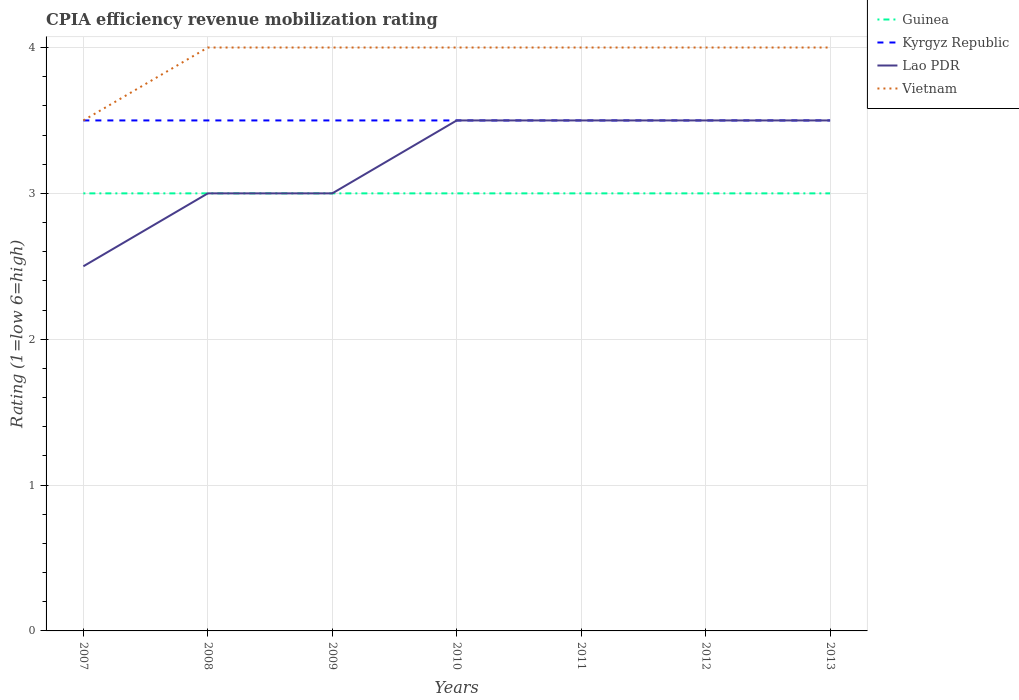Does the line corresponding to Vietnam intersect with the line corresponding to Kyrgyz Republic?
Give a very brief answer. Yes. In which year was the CPIA rating in Vietnam maximum?
Give a very brief answer. 2007. How many lines are there?
Make the answer very short. 4. What is the difference between two consecutive major ticks on the Y-axis?
Provide a short and direct response. 1. Are the values on the major ticks of Y-axis written in scientific E-notation?
Provide a succinct answer. No. Does the graph contain any zero values?
Keep it short and to the point. No. Does the graph contain grids?
Your answer should be compact. Yes. Where does the legend appear in the graph?
Ensure brevity in your answer.  Top right. What is the title of the graph?
Offer a terse response. CPIA efficiency revenue mobilization rating. Does "Marshall Islands" appear as one of the legend labels in the graph?
Your answer should be compact. No. What is the label or title of the X-axis?
Ensure brevity in your answer.  Years. What is the label or title of the Y-axis?
Ensure brevity in your answer.  Rating (1=low 6=high). What is the Rating (1=low 6=high) in Guinea in 2007?
Offer a terse response. 3. What is the Rating (1=low 6=high) of Guinea in 2008?
Your response must be concise. 3. What is the Rating (1=low 6=high) in Kyrgyz Republic in 2008?
Provide a succinct answer. 3.5. What is the Rating (1=low 6=high) in Lao PDR in 2008?
Offer a very short reply. 3. What is the Rating (1=low 6=high) in Kyrgyz Republic in 2009?
Give a very brief answer. 3.5. What is the Rating (1=low 6=high) of Guinea in 2010?
Your response must be concise. 3. What is the Rating (1=low 6=high) in Vietnam in 2010?
Provide a succinct answer. 4. What is the Rating (1=low 6=high) of Guinea in 2011?
Offer a very short reply. 3. What is the Rating (1=low 6=high) of Vietnam in 2011?
Make the answer very short. 4. What is the Rating (1=low 6=high) of Kyrgyz Republic in 2012?
Provide a succinct answer. 3.5. What is the Rating (1=low 6=high) in Lao PDR in 2012?
Offer a very short reply. 3.5. Across all years, what is the maximum Rating (1=low 6=high) in Guinea?
Provide a short and direct response. 3. Across all years, what is the maximum Rating (1=low 6=high) in Vietnam?
Offer a very short reply. 4. What is the total Rating (1=low 6=high) of Vietnam in the graph?
Ensure brevity in your answer.  27.5. What is the difference between the Rating (1=low 6=high) of Kyrgyz Republic in 2007 and that in 2008?
Your response must be concise. 0. What is the difference between the Rating (1=low 6=high) in Lao PDR in 2007 and that in 2008?
Ensure brevity in your answer.  -0.5. What is the difference between the Rating (1=low 6=high) of Kyrgyz Republic in 2007 and that in 2009?
Provide a short and direct response. 0. What is the difference between the Rating (1=low 6=high) of Lao PDR in 2007 and that in 2009?
Offer a terse response. -0.5. What is the difference between the Rating (1=low 6=high) in Guinea in 2007 and that in 2010?
Offer a terse response. 0. What is the difference between the Rating (1=low 6=high) in Lao PDR in 2007 and that in 2010?
Your answer should be compact. -1. What is the difference between the Rating (1=low 6=high) of Guinea in 2007 and that in 2011?
Keep it short and to the point. 0. What is the difference between the Rating (1=low 6=high) of Vietnam in 2007 and that in 2011?
Offer a very short reply. -0.5. What is the difference between the Rating (1=low 6=high) in Kyrgyz Republic in 2007 and that in 2013?
Make the answer very short. 0. What is the difference between the Rating (1=low 6=high) of Lao PDR in 2007 and that in 2013?
Your answer should be very brief. -1. What is the difference between the Rating (1=low 6=high) in Kyrgyz Republic in 2008 and that in 2009?
Your answer should be compact. 0. What is the difference between the Rating (1=low 6=high) of Guinea in 2008 and that in 2010?
Ensure brevity in your answer.  0. What is the difference between the Rating (1=low 6=high) in Kyrgyz Republic in 2008 and that in 2010?
Your response must be concise. 0. What is the difference between the Rating (1=low 6=high) of Vietnam in 2008 and that in 2010?
Provide a succinct answer. 0. What is the difference between the Rating (1=low 6=high) of Guinea in 2008 and that in 2011?
Offer a very short reply. 0. What is the difference between the Rating (1=low 6=high) in Lao PDR in 2008 and that in 2011?
Make the answer very short. -0.5. What is the difference between the Rating (1=low 6=high) of Kyrgyz Republic in 2008 and that in 2012?
Your response must be concise. 0. What is the difference between the Rating (1=low 6=high) in Lao PDR in 2008 and that in 2012?
Your response must be concise. -0.5. What is the difference between the Rating (1=low 6=high) in Guinea in 2008 and that in 2013?
Offer a terse response. 0. What is the difference between the Rating (1=low 6=high) in Lao PDR in 2008 and that in 2013?
Provide a succinct answer. -0.5. What is the difference between the Rating (1=low 6=high) in Lao PDR in 2009 and that in 2010?
Provide a succinct answer. -0.5. What is the difference between the Rating (1=low 6=high) in Lao PDR in 2009 and that in 2011?
Give a very brief answer. -0.5. What is the difference between the Rating (1=low 6=high) in Vietnam in 2009 and that in 2011?
Make the answer very short. 0. What is the difference between the Rating (1=low 6=high) in Lao PDR in 2009 and that in 2012?
Offer a very short reply. -0.5. What is the difference between the Rating (1=low 6=high) in Vietnam in 2009 and that in 2013?
Ensure brevity in your answer.  0. What is the difference between the Rating (1=low 6=high) of Guinea in 2010 and that in 2011?
Offer a very short reply. 0. What is the difference between the Rating (1=low 6=high) in Kyrgyz Republic in 2010 and that in 2011?
Ensure brevity in your answer.  0. What is the difference between the Rating (1=low 6=high) of Vietnam in 2010 and that in 2011?
Your answer should be very brief. 0. What is the difference between the Rating (1=low 6=high) in Kyrgyz Republic in 2010 and that in 2012?
Ensure brevity in your answer.  0. What is the difference between the Rating (1=low 6=high) of Vietnam in 2010 and that in 2012?
Your response must be concise. 0. What is the difference between the Rating (1=low 6=high) in Guinea in 2010 and that in 2013?
Your answer should be compact. 0. What is the difference between the Rating (1=low 6=high) in Vietnam in 2010 and that in 2013?
Ensure brevity in your answer.  0. What is the difference between the Rating (1=low 6=high) of Kyrgyz Republic in 2011 and that in 2012?
Offer a terse response. 0. What is the difference between the Rating (1=low 6=high) of Vietnam in 2011 and that in 2012?
Provide a short and direct response. 0. What is the difference between the Rating (1=low 6=high) of Guinea in 2011 and that in 2013?
Ensure brevity in your answer.  0. What is the difference between the Rating (1=low 6=high) of Kyrgyz Republic in 2011 and that in 2013?
Your answer should be very brief. 0. What is the difference between the Rating (1=low 6=high) in Guinea in 2012 and that in 2013?
Ensure brevity in your answer.  0. What is the difference between the Rating (1=low 6=high) of Kyrgyz Republic in 2012 and that in 2013?
Provide a succinct answer. 0. What is the difference between the Rating (1=low 6=high) of Guinea in 2007 and the Rating (1=low 6=high) of Kyrgyz Republic in 2008?
Offer a terse response. -0.5. What is the difference between the Rating (1=low 6=high) in Guinea in 2007 and the Rating (1=low 6=high) in Vietnam in 2008?
Your response must be concise. -1. What is the difference between the Rating (1=low 6=high) in Kyrgyz Republic in 2007 and the Rating (1=low 6=high) in Lao PDR in 2008?
Provide a short and direct response. 0.5. What is the difference between the Rating (1=low 6=high) in Lao PDR in 2007 and the Rating (1=low 6=high) in Vietnam in 2008?
Offer a very short reply. -1.5. What is the difference between the Rating (1=low 6=high) in Guinea in 2007 and the Rating (1=low 6=high) in Vietnam in 2009?
Keep it short and to the point. -1. What is the difference between the Rating (1=low 6=high) in Kyrgyz Republic in 2007 and the Rating (1=low 6=high) in Lao PDR in 2009?
Offer a terse response. 0.5. What is the difference between the Rating (1=low 6=high) in Kyrgyz Republic in 2007 and the Rating (1=low 6=high) in Vietnam in 2009?
Your answer should be compact. -0.5. What is the difference between the Rating (1=low 6=high) of Guinea in 2007 and the Rating (1=low 6=high) of Kyrgyz Republic in 2010?
Make the answer very short. -0.5. What is the difference between the Rating (1=low 6=high) of Kyrgyz Republic in 2007 and the Rating (1=low 6=high) of Lao PDR in 2010?
Ensure brevity in your answer.  0. What is the difference between the Rating (1=low 6=high) in Kyrgyz Republic in 2007 and the Rating (1=low 6=high) in Vietnam in 2010?
Give a very brief answer. -0.5. What is the difference between the Rating (1=low 6=high) of Guinea in 2007 and the Rating (1=low 6=high) of Vietnam in 2011?
Offer a terse response. -1. What is the difference between the Rating (1=low 6=high) in Guinea in 2007 and the Rating (1=low 6=high) in Lao PDR in 2012?
Your answer should be compact. -0.5. What is the difference between the Rating (1=low 6=high) of Guinea in 2007 and the Rating (1=low 6=high) of Vietnam in 2012?
Keep it short and to the point. -1. What is the difference between the Rating (1=low 6=high) in Kyrgyz Republic in 2007 and the Rating (1=low 6=high) in Vietnam in 2012?
Provide a short and direct response. -0.5. What is the difference between the Rating (1=low 6=high) in Guinea in 2007 and the Rating (1=low 6=high) in Kyrgyz Republic in 2013?
Provide a short and direct response. -0.5. What is the difference between the Rating (1=low 6=high) of Guinea in 2008 and the Rating (1=low 6=high) of Kyrgyz Republic in 2009?
Ensure brevity in your answer.  -0.5. What is the difference between the Rating (1=low 6=high) of Kyrgyz Republic in 2008 and the Rating (1=low 6=high) of Vietnam in 2009?
Provide a short and direct response. -0.5. What is the difference between the Rating (1=low 6=high) of Guinea in 2008 and the Rating (1=low 6=high) of Kyrgyz Republic in 2010?
Offer a terse response. -0.5. What is the difference between the Rating (1=low 6=high) of Kyrgyz Republic in 2008 and the Rating (1=low 6=high) of Lao PDR in 2010?
Offer a very short reply. 0. What is the difference between the Rating (1=low 6=high) of Lao PDR in 2008 and the Rating (1=low 6=high) of Vietnam in 2010?
Your answer should be very brief. -1. What is the difference between the Rating (1=low 6=high) of Guinea in 2008 and the Rating (1=low 6=high) of Kyrgyz Republic in 2011?
Your answer should be compact. -0.5. What is the difference between the Rating (1=low 6=high) of Kyrgyz Republic in 2008 and the Rating (1=low 6=high) of Lao PDR in 2011?
Offer a terse response. 0. What is the difference between the Rating (1=low 6=high) in Kyrgyz Republic in 2008 and the Rating (1=low 6=high) in Vietnam in 2011?
Your response must be concise. -0.5. What is the difference between the Rating (1=low 6=high) of Guinea in 2008 and the Rating (1=low 6=high) of Kyrgyz Republic in 2012?
Give a very brief answer. -0.5. What is the difference between the Rating (1=low 6=high) in Guinea in 2008 and the Rating (1=low 6=high) in Lao PDR in 2012?
Offer a very short reply. -0.5. What is the difference between the Rating (1=low 6=high) in Guinea in 2008 and the Rating (1=low 6=high) in Vietnam in 2012?
Give a very brief answer. -1. What is the difference between the Rating (1=low 6=high) of Guinea in 2008 and the Rating (1=low 6=high) of Lao PDR in 2013?
Offer a terse response. -0.5. What is the difference between the Rating (1=low 6=high) in Guinea in 2008 and the Rating (1=low 6=high) in Vietnam in 2013?
Provide a short and direct response. -1. What is the difference between the Rating (1=low 6=high) in Kyrgyz Republic in 2008 and the Rating (1=low 6=high) in Lao PDR in 2013?
Your answer should be very brief. 0. What is the difference between the Rating (1=low 6=high) of Guinea in 2009 and the Rating (1=low 6=high) of Kyrgyz Republic in 2010?
Provide a short and direct response. -0.5. What is the difference between the Rating (1=low 6=high) of Guinea in 2009 and the Rating (1=low 6=high) of Vietnam in 2010?
Your answer should be very brief. -1. What is the difference between the Rating (1=low 6=high) of Kyrgyz Republic in 2009 and the Rating (1=low 6=high) of Lao PDR in 2010?
Offer a very short reply. 0. What is the difference between the Rating (1=low 6=high) of Lao PDR in 2009 and the Rating (1=low 6=high) of Vietnam in 2010?
Your response must be concise. -1. What is the difference between the Rating (1=low 6=high) of Guinea in 2009 and the Rating (1=low 6=high) of Kyrgyz Republic in 2011?
Your answer should be compact. -0.5. What is the difference between the Rating (1=low 6=high) of Guinea in 2009 and the Rating (1=low 6=high) of Lao PDR in 2011?
Offer a terse response. -0.5. What is the difference between the Rating (1=low 6=high) of Kyrgyz Republic in 2009 and the Rating (1=low 6=high) of Lao PDR in 2011?
Give a very brief answer. 0. What is the difference between the Rating (1=low 6=high) in Guinea in 2009 and the Rating (1=low 6=high) in Lao PDR in 2012?
Offer a terse response. -0.5. What is the difference between the Rating (1=low 6=high) of Guinea in 2009 and the Rating (1=low 6=high) of Vietnam in 2012?
Provide a short and direct response. -1. What is the difference between the Rating (1=low 6=high) of Kyrgyz Republic in 2009 and the Rating (1=low 6=high) of Lao PDR in 2012?
Keep it short and to the point. 0. What is the difference between the Rating (1=low 6=high) of Lao PDR in 2009 and the Rating (1=low 6=high) of Vietnam in 2012?
Make the answer very short. -1. What is the difference between the Rating (1=low 6=high) in Lao PDR in 2009 and the Rating (1=low 6=high) in Vietnam in 2013?
Give a very brief answer. -1. What is the difference between the Rating (1=low 6=high) in Guinea in 2010 and the Rating (1=low 6=high) in Kyrgyz Republic in 2011?
Your response must be concise. -0.5. What is the difference between the Rating (1=low 6=high) in Guinea in 2010 and the Rating (1=low 6=high) in Vietnam in 2011?
Offer a terse response. -1. What is the difference between the Rating (1=low 6=high) of Kyrgyz Republic in 2010 and the Rating (1=low 6=high) of Vietnam in 2011?
Keep it short and to the point. -0.5. What is the difference between the Rating (1=low 6=high) in Guinea in 2010 and the Rating (1=low 6=high) in Kyrgyz Republic in 2012?
Offer a terse response. -0.5. What is the difference between the Rating (1=low 6=high) of Kyrgyz Republic in 2010 and the Rating (1=low 6=high) of Lao PDR in 2012?
Your answer should be compact. 0. What is the difference between the Rating (1=low 6=high) in Kyrgyz Republic in 2010 and the Rating (1=low 6=high) in Vietnam in 2012?
Give a very brief answer. -0.5. What is the difference between the Rating (1=low 6=high) in Guinea in 2010 and the Rating (1=low 6=high) in Vietnam in 2013?
Provide a succinct answer. -1. What is the difference between the Rating (1=low 6=high) in Lao PDR in 2010 and the Rating (1=low 6=high) in Vietnam in 2013?
Ensure brevity in your answer.  -0.5. What is the difference between the Rating (1=low 6=high) in Guinea in 2011 and the Rating (1=low 6=high) in Vietnam in 2012?
Your answer should be compact. -1. What is the difference between the Rating (1=low 6=high) of Kyrgyz Republic in 2011 and the Rating (1=low 6=high) of Vietnam in 2012?
Make the answer very short. -0.5. What is the difference between the Rating (1=low 6=high) of Guinea in 2011 and the Rating (1=low 6=high) of Kyrgyz Republic in 2013?
Offer a terse response. -0.5. What is the difference between the Rating (1=low 6=high) of Kyrgyz Republic in 2011 and the Rating (1=low 6=high) of Vietnam in 2013?
Ensure brevity in your answer.  -0.5. What is the difference between the Rating (1=low 6=high) of Guinea in 2012 and the Rating (1=low 6=high) of Vietnam in 2013?
Offer a very short reply. -1. What is the difference between the Rating (1=low 6=high) of Kyrgyz Republic in 2012 and the Rating (1=low 6=high) of Vietnam in 2013?
Your answer should be compact. -0.5. What is the difference between the Rating (1=low 6=high) of Lao PDR in 2012 and the Rating (1=low 6=high) of Vietnam in 2013?
Offer a terse response. -0.5. What is the average Rating (1=low 6=high) in Kyrgyz Republic per year?
Ensure brevity in your answer.  3.5. What is the average Rating (1=low 6=high) in Lao PDR per year?
Provide a short and direct response. 3.21. What is the average Rating (1=low 6=high) in Vietnam per year?
Your answer should be compact. 3.93. In the year 2007, what is the difference between the Rating (1=low 6=high) of Guinea and Rating (1=low 6=high) of Kyrgyz Republic?
Give a very brief answer. -0.5. In the year 2007, what is the difference between the Rating (1=low 6=high) of Kyrgyz Republic and Rating (1=low 6=high) of Lao PDR?
Ensure brevity in your answer.  1. In the year 2007, what is the difference between the Rating (1=low 6=high) in Kyrgyz Republic and Rating (1=low 6=high) in Vietnam?
Your response must be concise. 0. In the year 2007, what is the difference between the Rating (1=low 6=high) of Lao PDR and Rating (1=low 6=high) of Vietnam?
Your answer should be very brief. -1. In the year 2008, what is the difference between the Rating (1=low 6=high) of Guinea and Rating (1=low 6=high) of Kyrgyz Republic?
Offer a very short reply. -0.5. In the year 2008, what is the difference between the Rating (1=low 6=high) of Guinea and Rating (1=low 6=high) of Vietnam?
Provide a short and direct response. -1. In the year 2008, what is the difference between the Rating (1=low 6=high) in Kyrgyz Republic and Rating (1=low 6=high) in Lao PDR?
Provide a succinct answer. 0.5. In the year 2009, what is the difference between the Rating (1=low 6=high) of Guinea and Rating (1=low 6=high) of Kyrgyz Republic?
Offer a very short reply. -0.5. In the year 2009, what is the difference between the Rating (1=low 6=high) of Guinea and Rating (1=low 6=high) of Lao PDR?
Provide a short and direct response. 0. In the year 2009, what is the difference between the Rating (1=low 6=high) of Guinea and Rating (1=low 6=high) of Vietnam?
Provide a succinct answer. -1. In the year 2009, what is the difference between the Rating (1=low 6=high) of Kyrgyz Republic and Rating (1=low 6=high) of Vietnam?
Offer a terse response. -0.5. In the year 2009, what is the difference between the Rating (1=low 6=high) of Lao PDR and Rating (1=low 6=high) of Vietnam?
Your response must be concise. -1. In the year 2010, what is the difference between the Rating (1=low 6=high) of Guinea and Rating (1=low 6=high) of Vietnam?
Offer a terse response. -1. In the year 2010, what is the difference between the Rating (1=low 6=high) in Kyrgyz Republic and Rating (1=low 6=high) in Vietnam?
Offer a terse response. -0.5. In the year 2012, what is the difference between the Rating (1=low 6=high) in Guinea and Rating (1=low 6=high) in Kyrgyz Republic?
Your answer should be compact. -0.5. In the year 2012, what is the difference between the Rating (1=low 6=high) of Guinea and Rating (1=low 6=high) of Vietnam?
Offer a very short reply. -1. In the year 2012, what is the difference between the Rating (1=low 6=high) in Kyrgyz Republic and Rating (1=low 6=high) in Lao PDR?
Provide a short and direct response. 0. In the year 2012, what is the difference between the Rating (1=low 6=high) of Kyrgyz Republic and Rating (1=low 6=high) of Vietnam?
Your response must be concise. -0.5. In the year 2013, what is the difference between the Rating (1=low 6=high) in Guinea and Rating (1=low 6=high) in Kyrgyz Republic?
Your answer should be very brief. -0.5. In the year 2013, what is the difference between the Rating (1=low 6=high) in Guinea and Rating (1=low 6=high) in Lao PDR?
Your answer should be very brief. -0.5. In the year 2013, what is the difference between the Rating (1=low 6=high) of Guinea and Rating (1=low 6=high) of Vietnam?
Make the answer very short. -1. In the year 2013, what is the difference between the Rating (1=low 6=high) in Kyrgyz Republic and Rating (1=low 6=high) in Vietnam?
Provide a short and direct response. -0.5. In the year 2013, what is the difference between the Rating (1=low 6=high) in Lao PDR and Rating (1=low 6=high) in Vietnam?
Your answer should be very brief. -0.5. What is the ratio of the Rating (1=low 6=high) in Kyrgyz Republic in 2007 to that in 2008?
Offer a terse response. 1. What is the ratio of the Rating (1=low 6=high) in Vietnam in 2007 to that in 2008?
Provide a short and direct response. 0.88. What is the ratio of the Rating (1=low 6=high) in Kyrgyz Republic in 2007 to that in 2009?
Give a very brief answer. 1. What is the ratio of the Rating (1=low 6=high) of Guinea in 2007 to that in 2010?
Ensure brevity in your answer.  1. What is the ratio of the Rating (1=low 6=high) of Kyrgyz Republic in 2007 to that in 2010?
Offer a very short reply. 1. What is the ratio of the Rating (1=low 6=high) of Lao PDR in 2007 to that in 2010?
Your answer should be compact. 0.71. What is the ratio of the Rating (1=low 6=high) in Vietnam in 2007 to that in 2011?
Keep it short and to the point. 0.88. What is the ratio of the Rating (1=low 6=high) of Guinea in 2007 to that in 2012?
Offer a terse response. 1. What is the ratio of the Rating (1=low 6=high) in Kyrgyz Republic in 2007 to that in 2012?
Your response must be concise. 1. What is the ratio of the Rating (1=low 6=high) of Lao PDR in 2007 to that in 2012?
Ensure brevity in your answer.  0.71. What is the ratio of the Rating (1=low 6=high) in Vietnam in 2007 to that in 2012?
Offer a terse response. 0.88. What is the ratio of the Rating (1=low 6=high) of Kyrgyz Republic in 2007 to that in 2013?
Provide a short and direct response. 1. What is the ratio of the Rating (1=low 6=high) in Vietnam in 2007 to that in 2013?
Keep it short and to the point. 0.88. What is the ratio of the Rating (1=low 6=high) in Guinea in 2008 to that in 2009?
Your answer should be very brief. 1. What is the ratio of the Rating (1=low 6=high) in Lao PDR in 2008 to that in 2009?
Your answer should be very brief. 1. What is the ratio of the Rating (1=low 6=high) in Vietnam in 2008 to that in 2009?
Your answer should be compact. 1. What is the ratio of the Rating (1=low 6=high) in Guinea in 2008 to that in 2010?
Your response must be concise. 1. What is the ratio of the Rating (1=low 6=high) of Kyrgyz Republic in 2008 to that in 2010?
Keep it short and to the point. 1. What is the ratio of the Rating (1=low 6=high) of Lao PDR in 2008 to that in 2010?
Provide a short and direct response. 0.86. What is the ratio of the Rating (1=low 6=high) of Vietnam in 2008 to that in 2010?
Ensure brevity in your answer.  1. What is the ratio of the Rating (1=low 6=high) of Lao PDR in 2008 to that in 2011?
Ensure brevity in your answer.  0.86. What is the ratio of the Rating (1=low 6=high) in Guinea in 2008 to that in 2012?
Offer a very short reply. 1. What is the ratio of the Rating (1=low 6=high) in Kyrgyz Republic in 2008 to that in 2012?
Give a very brief answer. 1. What is the ratio of the Rating (1=low 6=high) of Lao PDR in 2008 to that in 2012?
Make the answer very short. 0.86. What is the ratio of the Rating (1=low 6=high) in Kyrgyz Republic in 2008 to that in 2013?
Your answer should be compact. 1. What is the ratio of the Rating (1=low 6=high) in Lao PDR in 2008 to that in 2013?
Give a very brief answer. 0.86. What is the ratio of the Rating (1=low 6=high) of Vietnam in 2008 to that in 2013?
Offer a very short reply. 1. What is the ratio of the Rating (1=low 6=high) of Kyrgyz Republic in 2009 to that in 2010?
Provide a short and direct response. 1. What is the ratio of the Rating (1=low 6=high) in Lao PDR in 2009 to that in 2010?
Your response must be concise. 0.86. What is the ratio of the Rating (1=low 6=high) of Vietnam in 2009 to that in 2010?
Your answer should be very brief. 1. What is the ratio of the Rating (1=low 6=high) in Guinea in 2009 to that in 2011?
Provide a short and direct response. 1. What is the ratio of the Rating (1=low 6=high) of Kyrgyz Republic in 2009 to that in 2011?
Offer a very short reply. 1. What is the ratio of the Rating (1=low 6=high) in Lao PDR in 2009 to that in 2011?
Ensure brevity in your answer.  0.86. What is the ratio of the Rating (1=low 6=high) in Vietnam in 2009 to that in 2011?
Ensure brevity in your answer.  1. What is the ratio of the Rating (1=low 6=high) in Kyrgyz Republic in 2009 to that in 2012?
Offer a terse response. 1. What is the ratio of the Rating (1=low 6=high) in Vietnam in 2009 to that in 2012?
Provide a succinct answer. 1. What is the ratio of the Rating (1=low 6=high) of Guinea in 2009 to that in 2013?
Your response must be concise. 1. What is the ratio of the Rating (1=low 6=high) in Lao PDR in 2009 to that in 2013?
Ensure brevity in your answer.  0.86. What is the ratio of the Rating (1=low 6=high) in Vietnam in 2009 to that in 2013?
Ensure brevity in your answer.  1. What is the ratio of the Rating (1=low 6=high) in Guinea in 2010 to that in 2011?
Provide a succinct answer. 1. What is the ratio of the Rating (1=low 6=high) of Lao PDR in 2010 to that in 2011?
Your response must be concise. 1. What is the ratio of the Rating (1=low 6=high) in Kyrgyz Republic in 2010 to that in 2012?
Offer a very short reply. 1. What is the ratio of the Rating (1=low 6=high) in Kyrgyz Republic in 2010 to that in 2013?
Offer a very short reply. 1. What is the ratio of the Rating (1=low 6=high) of Vietnam in 2010 to that in 2013?
Provide a succinct answer. 1. What is the ratio of the Rating (1=low 6=high) of Guinea in 2011 to that in 2012?
Your answer should be very brief. 1. What is the ratio of the Rating (1=low 6=high) in Vietnam in 2011 to that in 2012?
Offer a very short reply. 1. What is the ratio of the Rating (1=low 6=high) in Kyrgyz Republic in 2011 to that in 2013?
Offer a terse response. 1. What is the ratio of the Rating (1=low 6=high) in Guinea in 2012 to that in 2013?
Provide a short and direct response. 1. What is the ratio of the Rating (1=low 6=high) of Vietnam in 2012 to that in 2013?
Make the answer very short. 1. What is the difference between the highest and the second highest Rating (1=low 6=high) in Guinea?
Your answer should be very brief. 0. What is the difference between the highest and the lowest Rating (1=low 6=high) of Kyrgyz Republic?
Make the answer very short. 0. What is the difference between the highest and the lowest Rating (1=low 6=high) of Lao PDR?
Ensure brevity in your answer.  1. What is the difference between the highest and the lowest Rating (1=low 6=high) of Vietnam?
Ensure brevity in your answer.  0.5. 